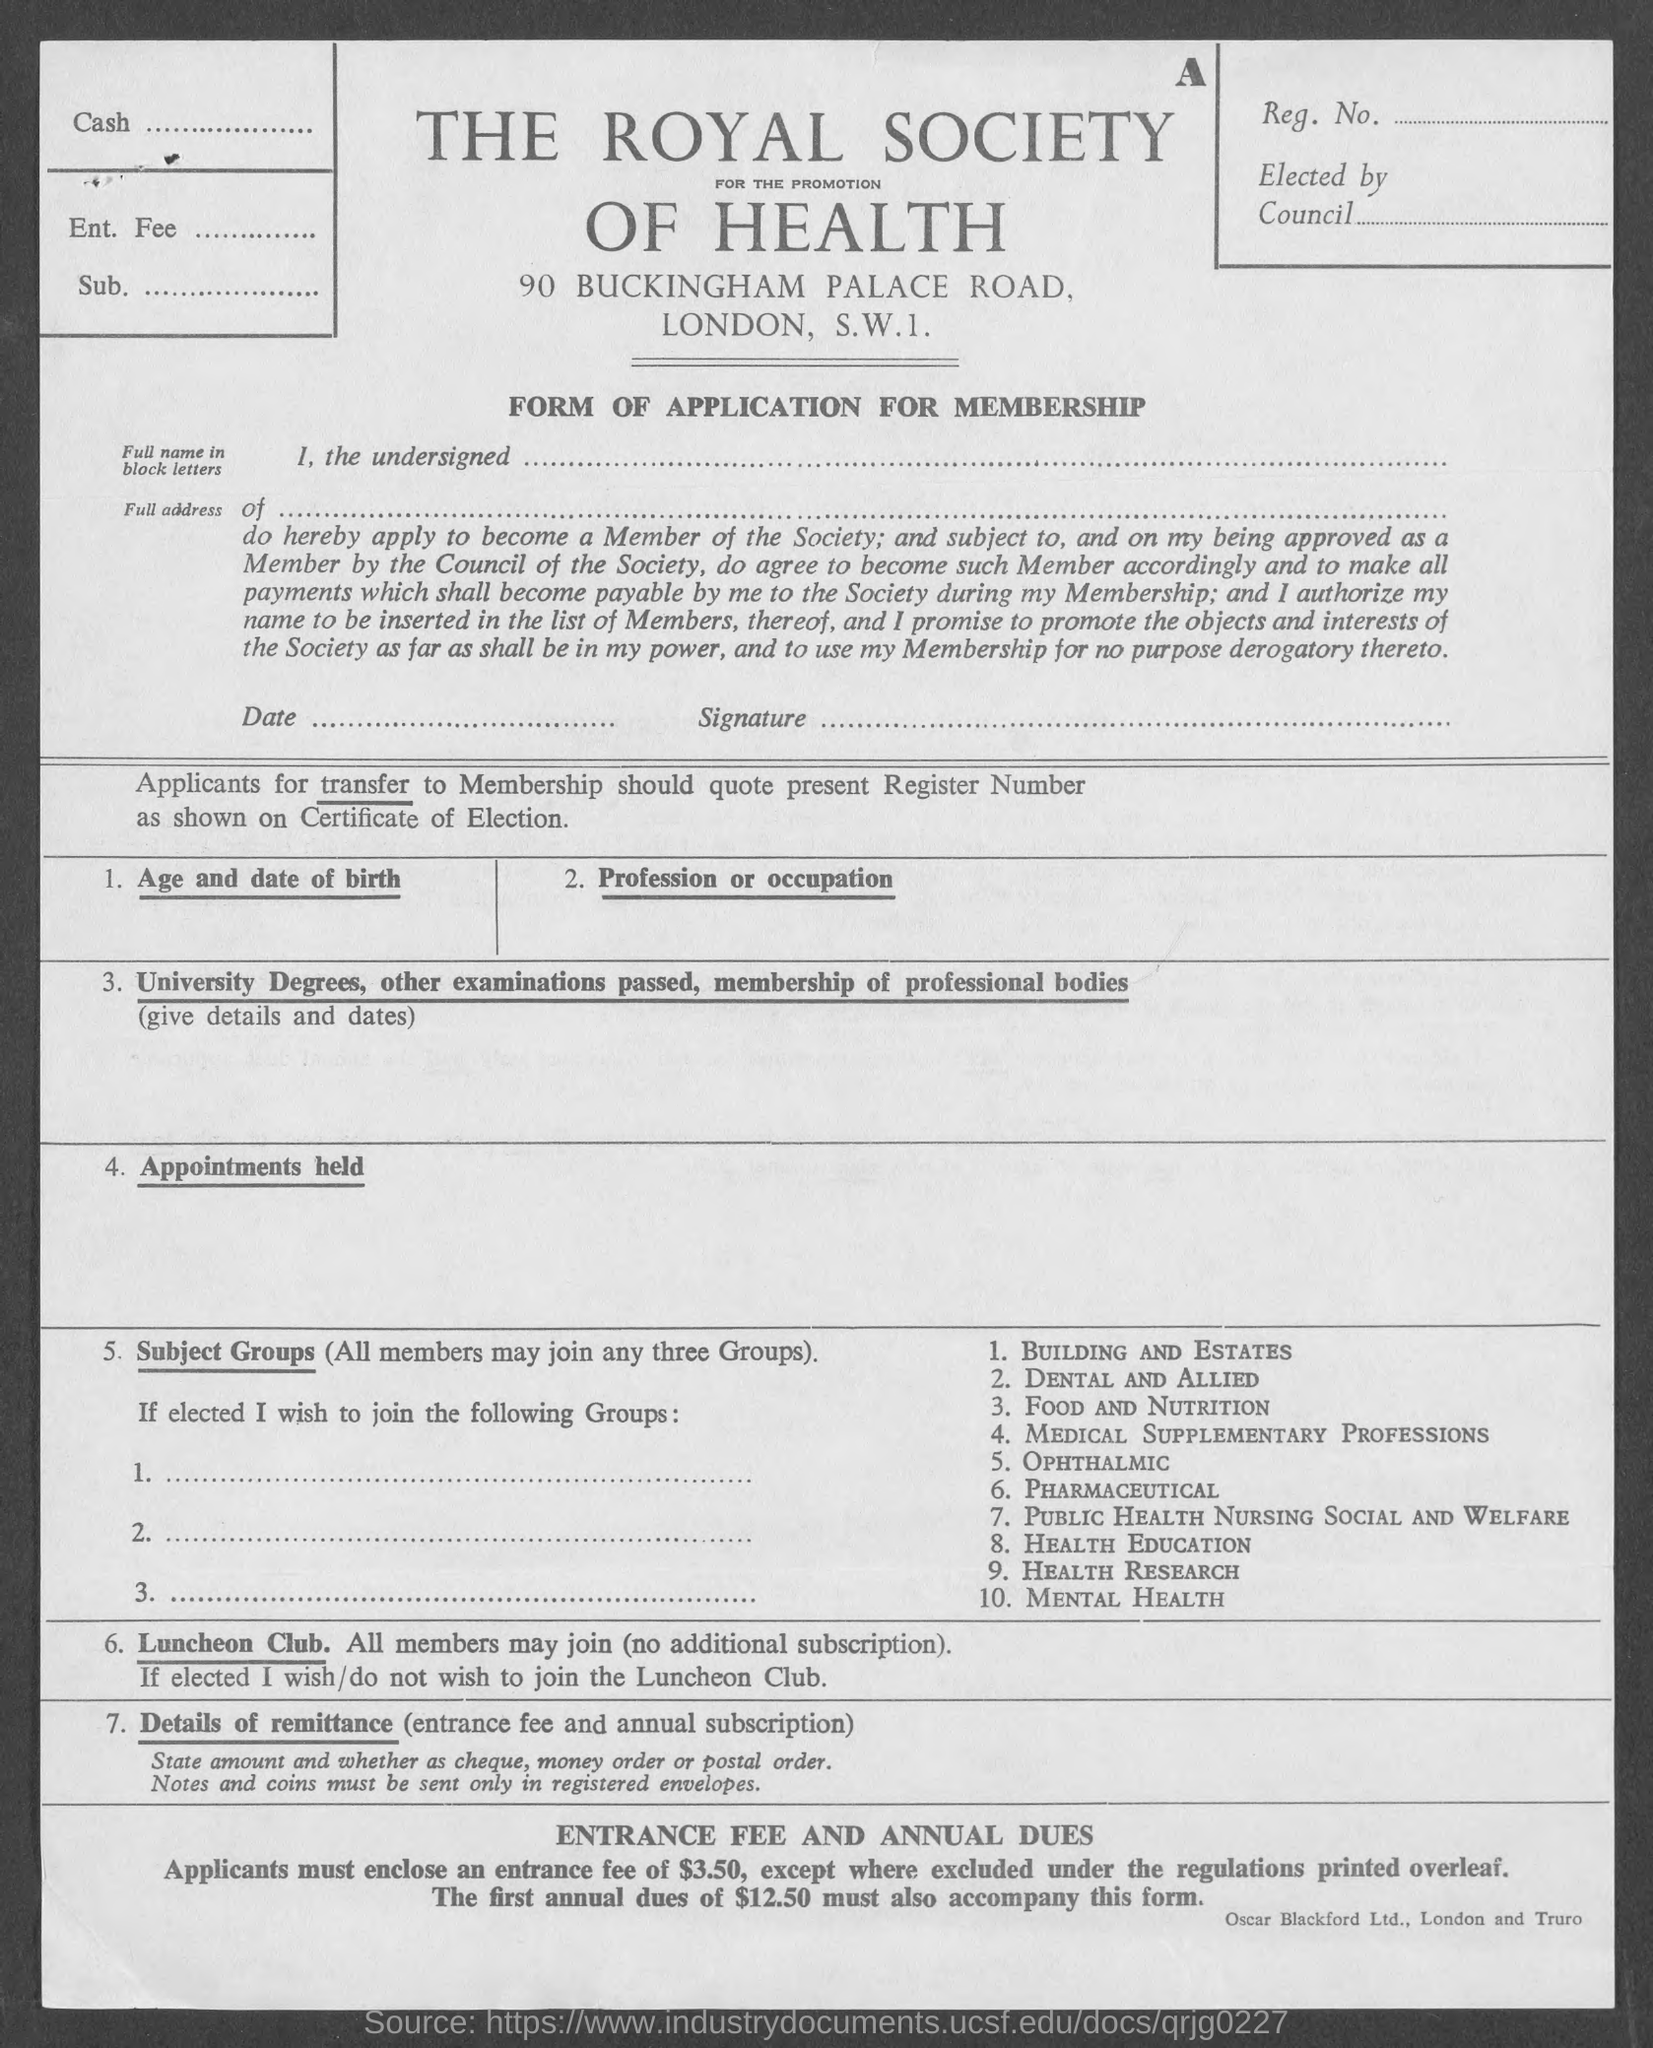What is the name of the form mentioned in the given page ?
Ensure brevity in your answer.  Form of application for membership. 